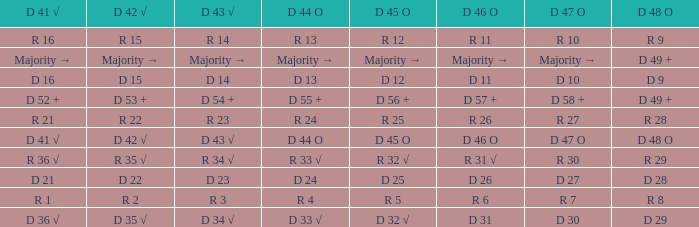Name the D 41 √ with D 44 O of r 13 R 16. 